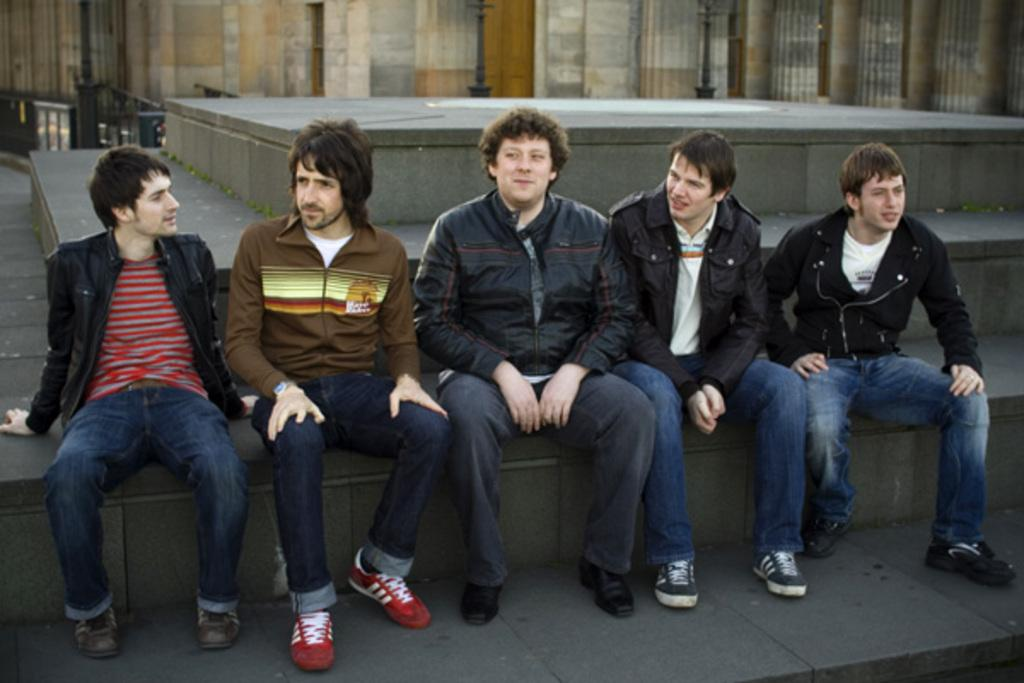What are the people in the image doing? The people in the image are sitting on a platform. What can be seen in the background of the image? There is a wall visible in the background of the image. What type of pump is being used by the people sitting on the platform in the image? There is no pump present in the image; the people are simply sitting on a platform. 